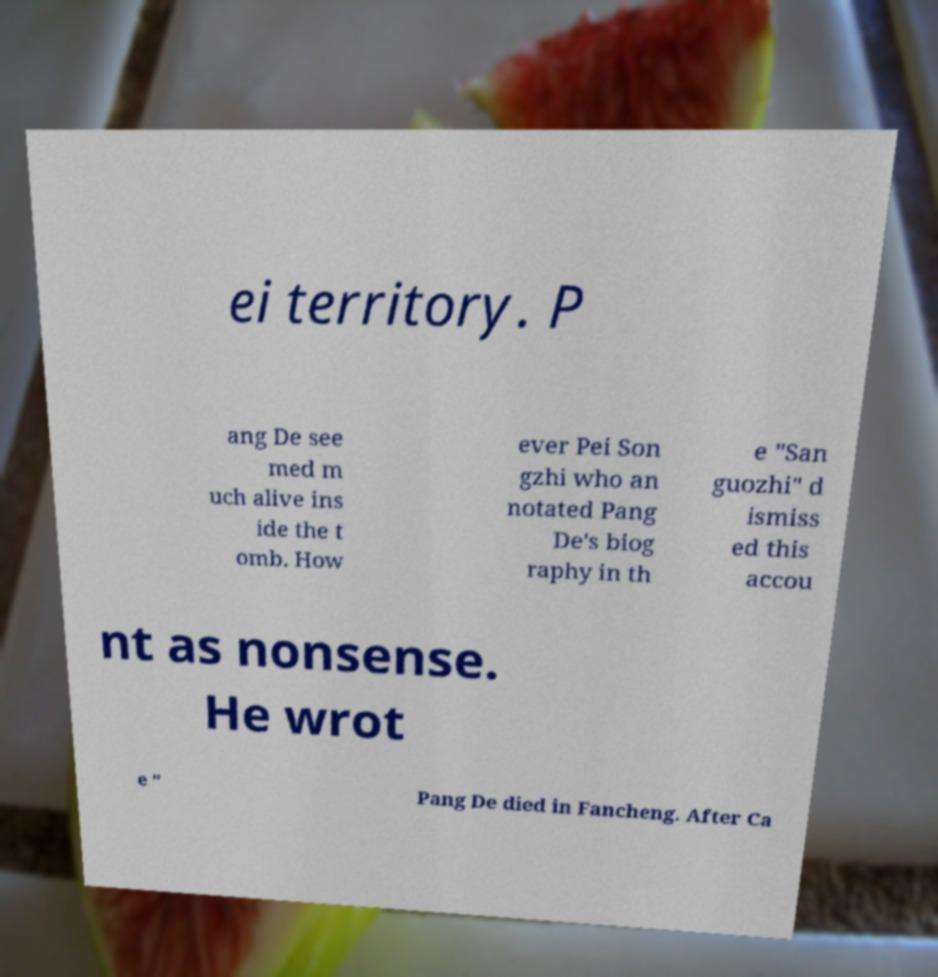Could you assist in decoding the text presented in this image and type it out clearly? ei territory. P ang De see med m uch alive ins ide the t omb. How ever Pei Son gzhi who an notated Pang De's biog raphy in th e "San guozhi" d ismiss ed this accou nt as nonsense. He wrot e " Pang De died in Fancheng. After Ca 